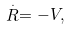<formula> <loc_0><loc_0><loc_500><loc_500>\stackrel { . } { R } = - V ,</formula> 